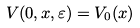Convert formula to latex. <formula><loc_0><loc_0><loc_500><loc_500>V ( 0 , x , \varepsilon ) = V _ { 0 } ( x )</formula> 